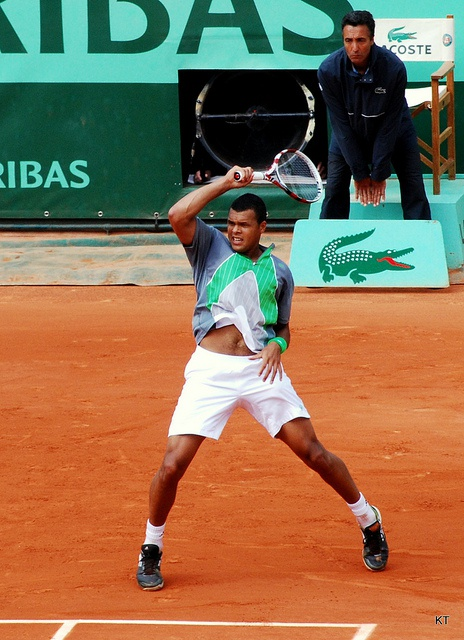Describe the objects in this image and their specific colors. I can see people in darkgreen, white, maroon, black, and red tones, people in darkgreen, black, maroon, navy, and brown tones, chair in darkgreen, black, maroon, and brown tones, chair in darkgreen, ivory, lightblue, and teal tones, and tennis racket in darkgreen, lightgray, gray, black, and darkgray tones in this image. 